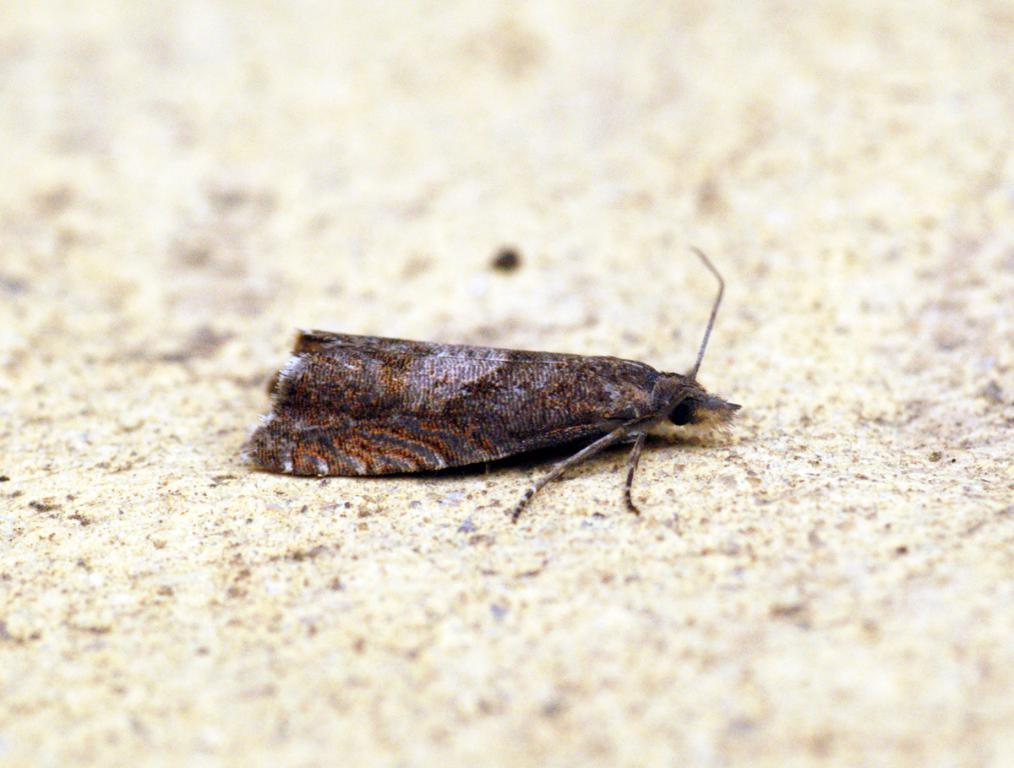What type of creature is in the image? There is an insect in the image. What colors can be seen on the insect? The insect has black and brown coloration. What is the background or surface that the insect is on? The insect is on a cream-colored surface. What type of circle can be seen in the image? There is no circle present in the image. What territory does the insect inhabit in the image? The image does not provide information about the insect's territory. 